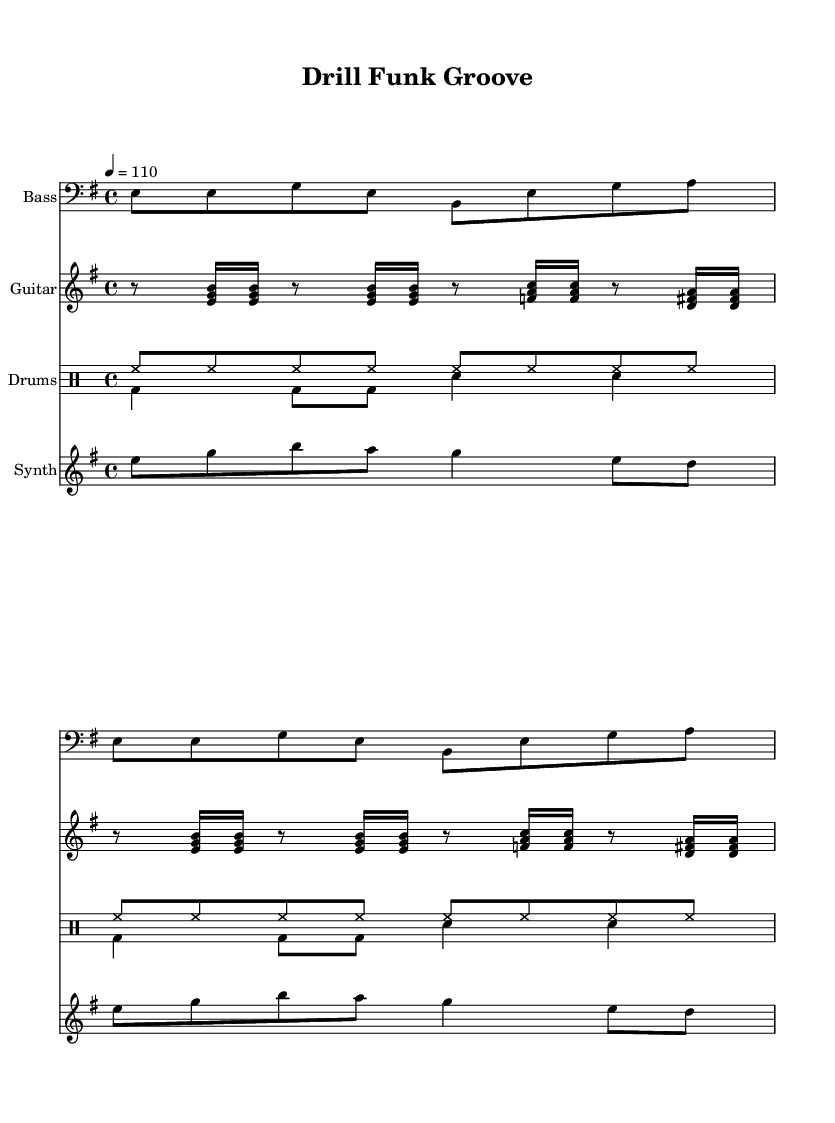What is the key signature of this music? The key signature is indicated at the beginning of the staff, which shows E minor having one sharp (F#).
Answer: E minor What is the time signature of the piece? The time signature is located at the beginning of the staff, displaying a 4 over 4, meaning there are four beats in every measure.
Answer: 4/4 What is the tempo of the track? The tempo is indicated at the beginning with a quarter note equals 110 beats per minute. This suggests a moderate tempo suitable for Funk music.
Answer: 110 How many measures are in the bass line repetition? The bass line is set to repeat twice, as indicated by the "repeat unfold" instruction, which shows that each section is played two times.
Answer: 2 What rhythmic pattern is used for the drums? The drum patterns are displayed in drummode. The first pattern consists of hi-hats in a steady rhythm, while the second alternates between bass drum and snare drum, indicating a typical Funk rhythm.
Answer: Funk rhythm What instruments are included in this piece? The piece includes a bass, guitar, drums, and synth, as listed under each staff's instrument name.
Answer: Bass, guitar, drums, synth What is the main function of the synth melody in this track? The synth melody usually serves to add a melodic line that complements the groove established by the bass and drums, enhancing the overall Funk feel.
Answer: Complementary melody 